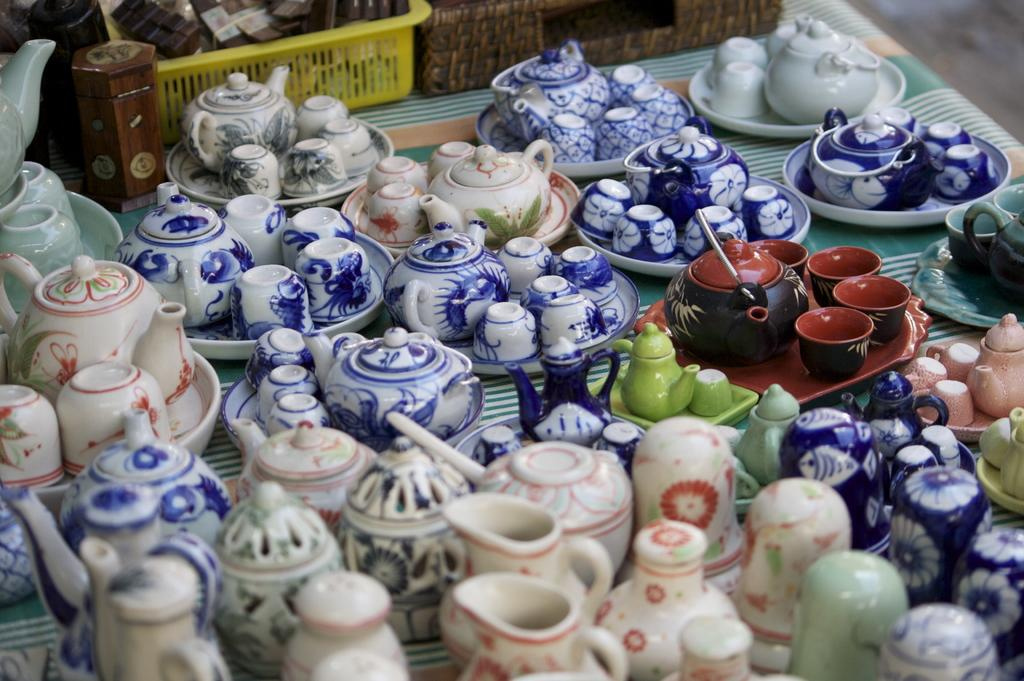What type of objects are present on the table in the image? There are ceramic kettles, cups, and saucers on the table in the image. What other items can be seen in the background of the image? There is a tray with vessels in the background of the image. How many beds are visible in the image? There are no beds present in the image. What type of assistance can be provided by the ceramic kettles in the image? The ceramic kettles in the image are not capable of providing assistance, as they are inanimate objects. 